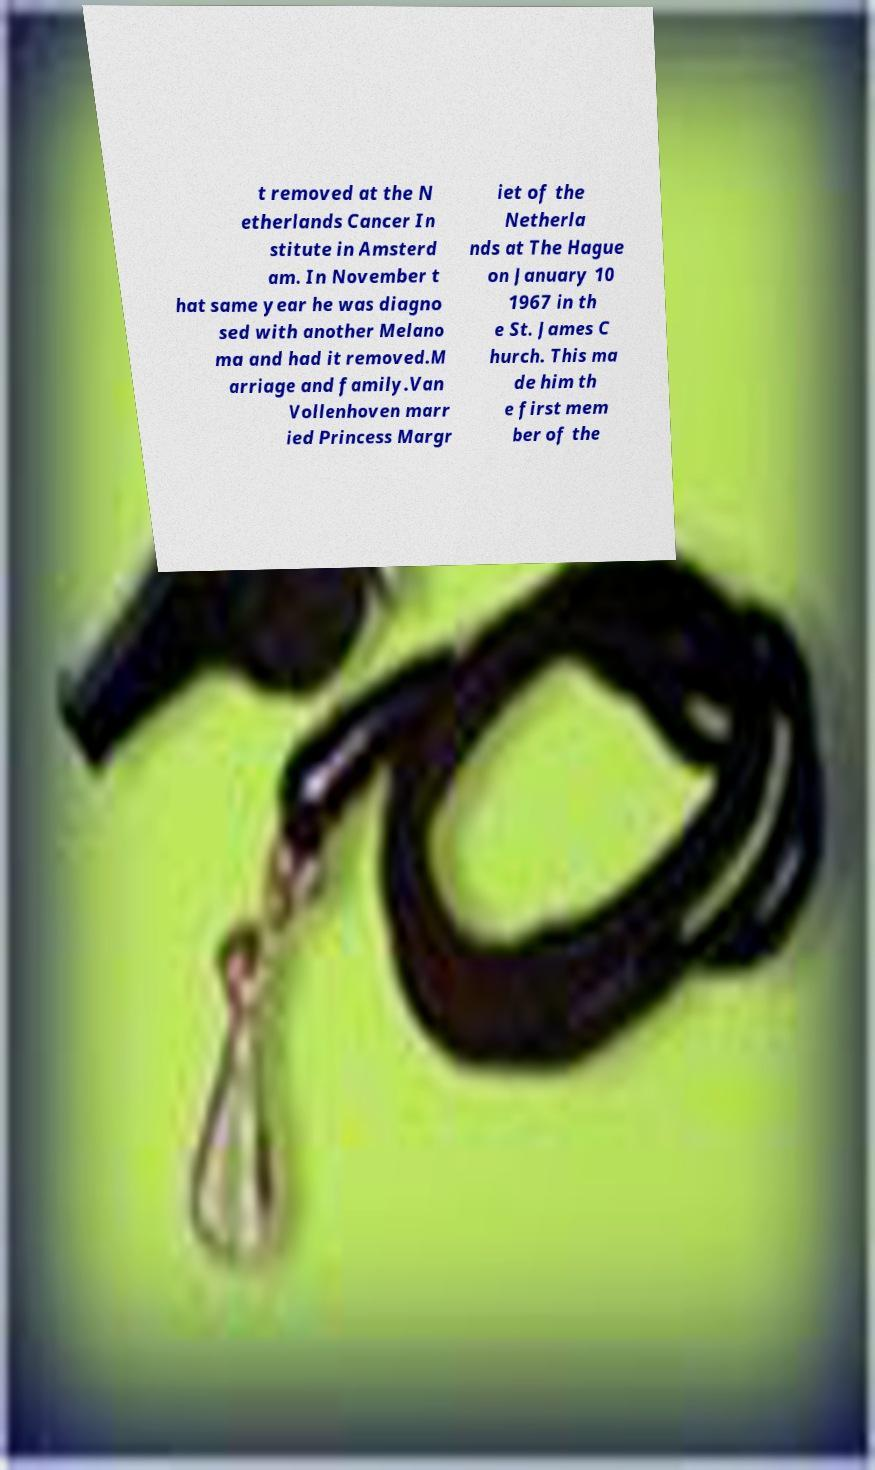There's text embedded in this image that I need extracted. Can you transcribe it verbatim? t removed at the N etherlands Cancer In stitute in Amsterd am. In November t hat same year he was diagno sed with another Melano ma and had it removed.M arriage and family.Van Vollenhoven marr ied Princess Margr iet of the Netherla nds at The Hague on January 10 1967 in th e St. James C hurch. This ma de him th e first mem ber of the 